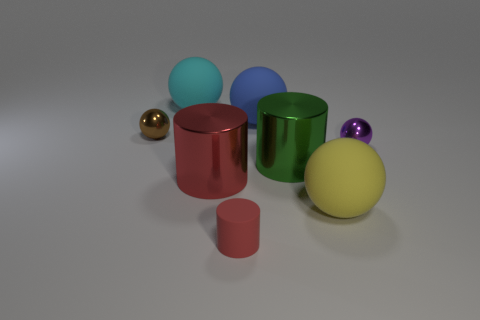Can you tell which object is at the forefront of the image? The object that appears to be at the forefront of the image, suggesting the closest position to the viewer, is the small pink metallic cylinder. Its size and placement relative to the other objects give the impression that it is the nearest. What can you deduce about the lighting in the scene from the shadows? The shadows in the scene are soft and diffuse, indicating that the lighting is likely coming from a broad source. The direction of the shadows suggests that the light source is situated above and to the right side of the scene. This type of lighting tends to create a soft, even illumination that minimizes harsh shadows and is often used to convey a calm and clear environment. 